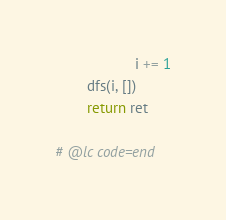<code> <loc_0><loc_0><loc_500><loc_500><_Python_>                    i += 1
        dfs(i, [])
        return ret

# @lc code=end

</code> 